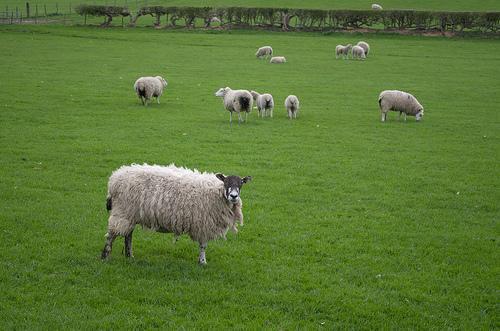How many sheep are there?
Give a very brief answer. 11. 